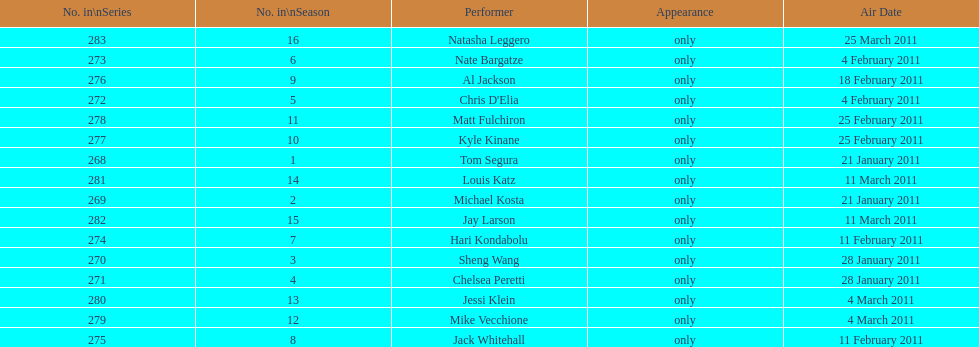Who appeared first tom segura or jay larson? Tom Segura. 